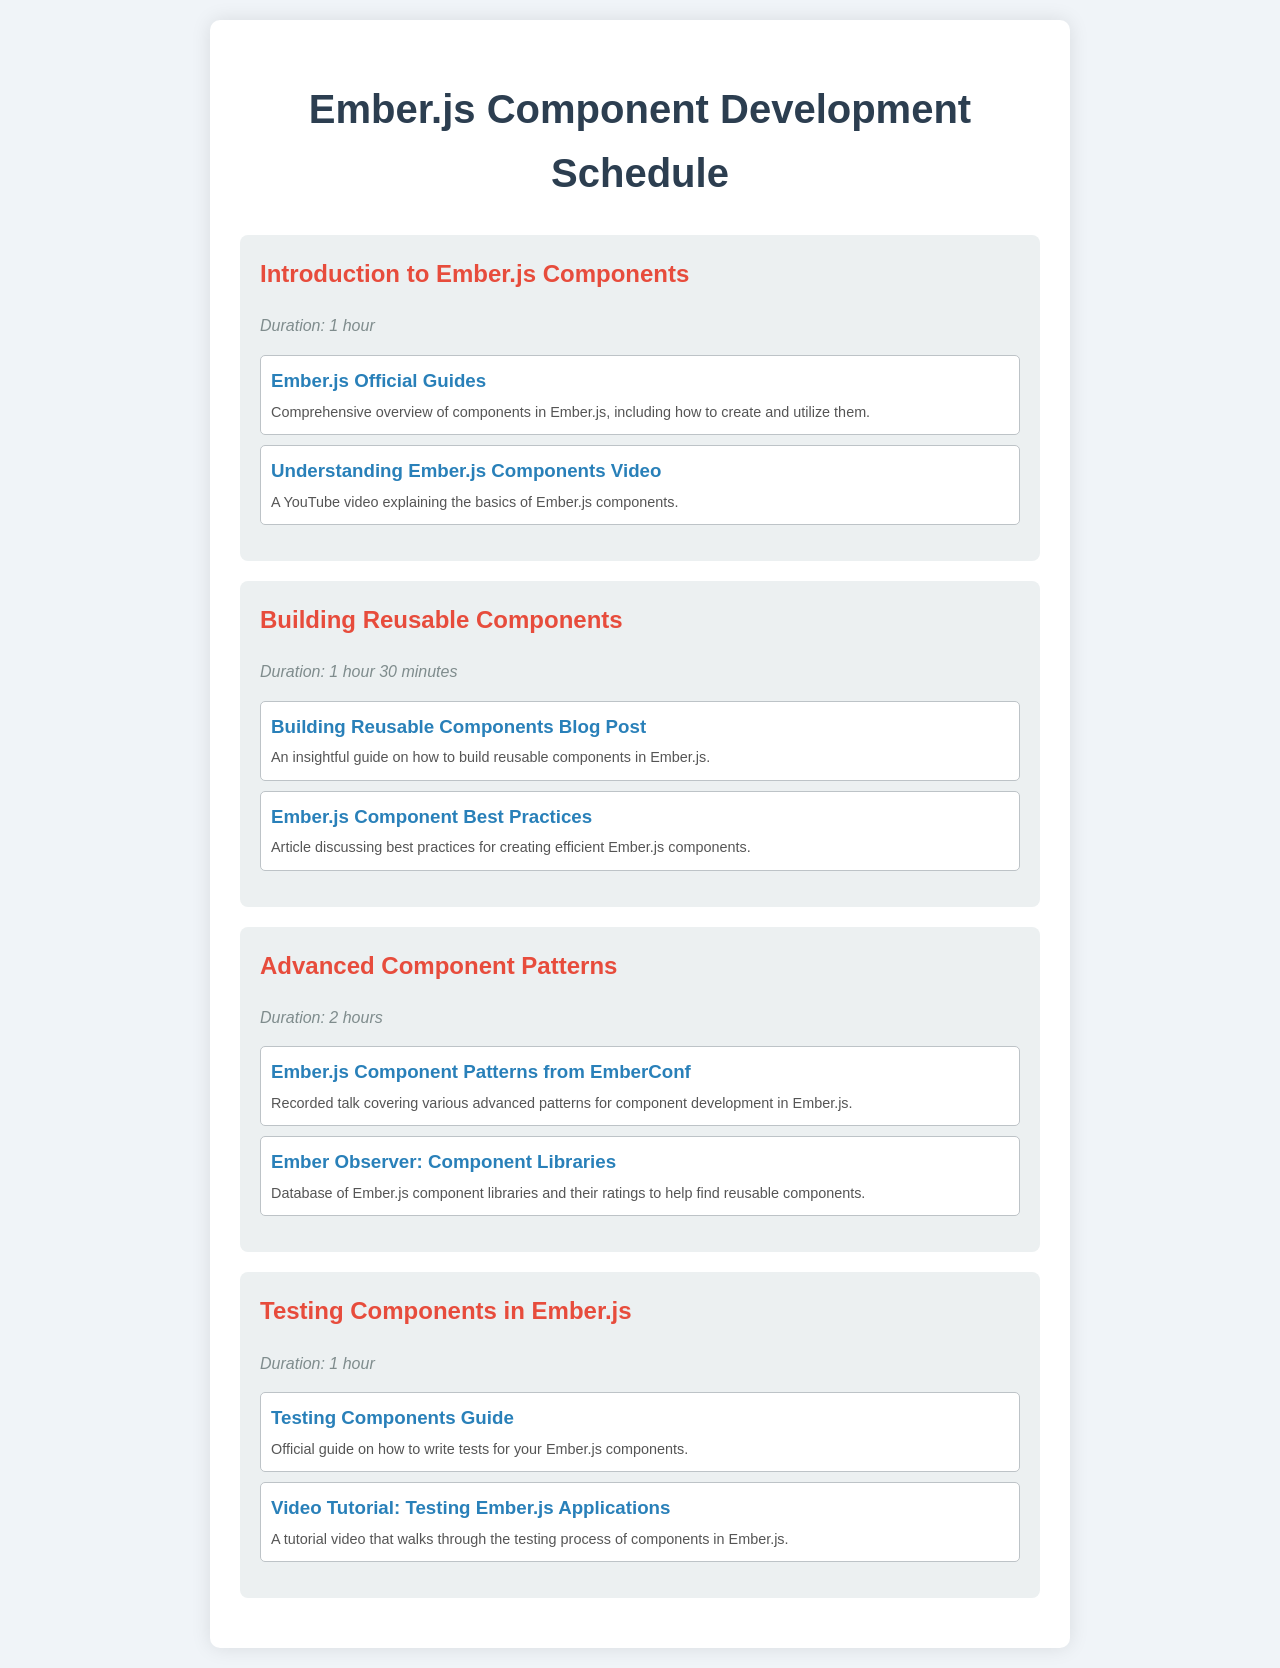what is the title of the document? The title of the document is displayed prominently at the top of the page.
Answer: Ember.js Component Development Schedule how many sessions are listed in the schedule? The number of sessions can be counted from the document's structure, where each session is clearly defined.
Answer: 4 what is the duration of the "Building Reusable Components" session? The duration is mentioned right below the session title, providing specific time information.
Answer: 1 hour 30 minutes which session covers testing components? This question requires identifying the session specifically focused on testing components from the schedule.
Answer: Testing Components in Ember.js name one resource listed for learning about advanced component patterns. The resources provided under the session titles offer specific articles or talks; identifying one is essential.
Answer: Ember.js Component Patterns from EmberConf how long is the session focused on advanced component patterns? The session's duration is stated as part of the session details, outlining the time commitment needed.
Answer: 2 hours which platform hosts the video tutorial on testing Ember.js applications? The link provided indicates where the video tutorial can be found, revealing the platform hosting it.
Answer: YouTube what color is used for the session titles? The document includes design aspects where colors are mentioned, indicating the visual style applied.
Answer: Red 